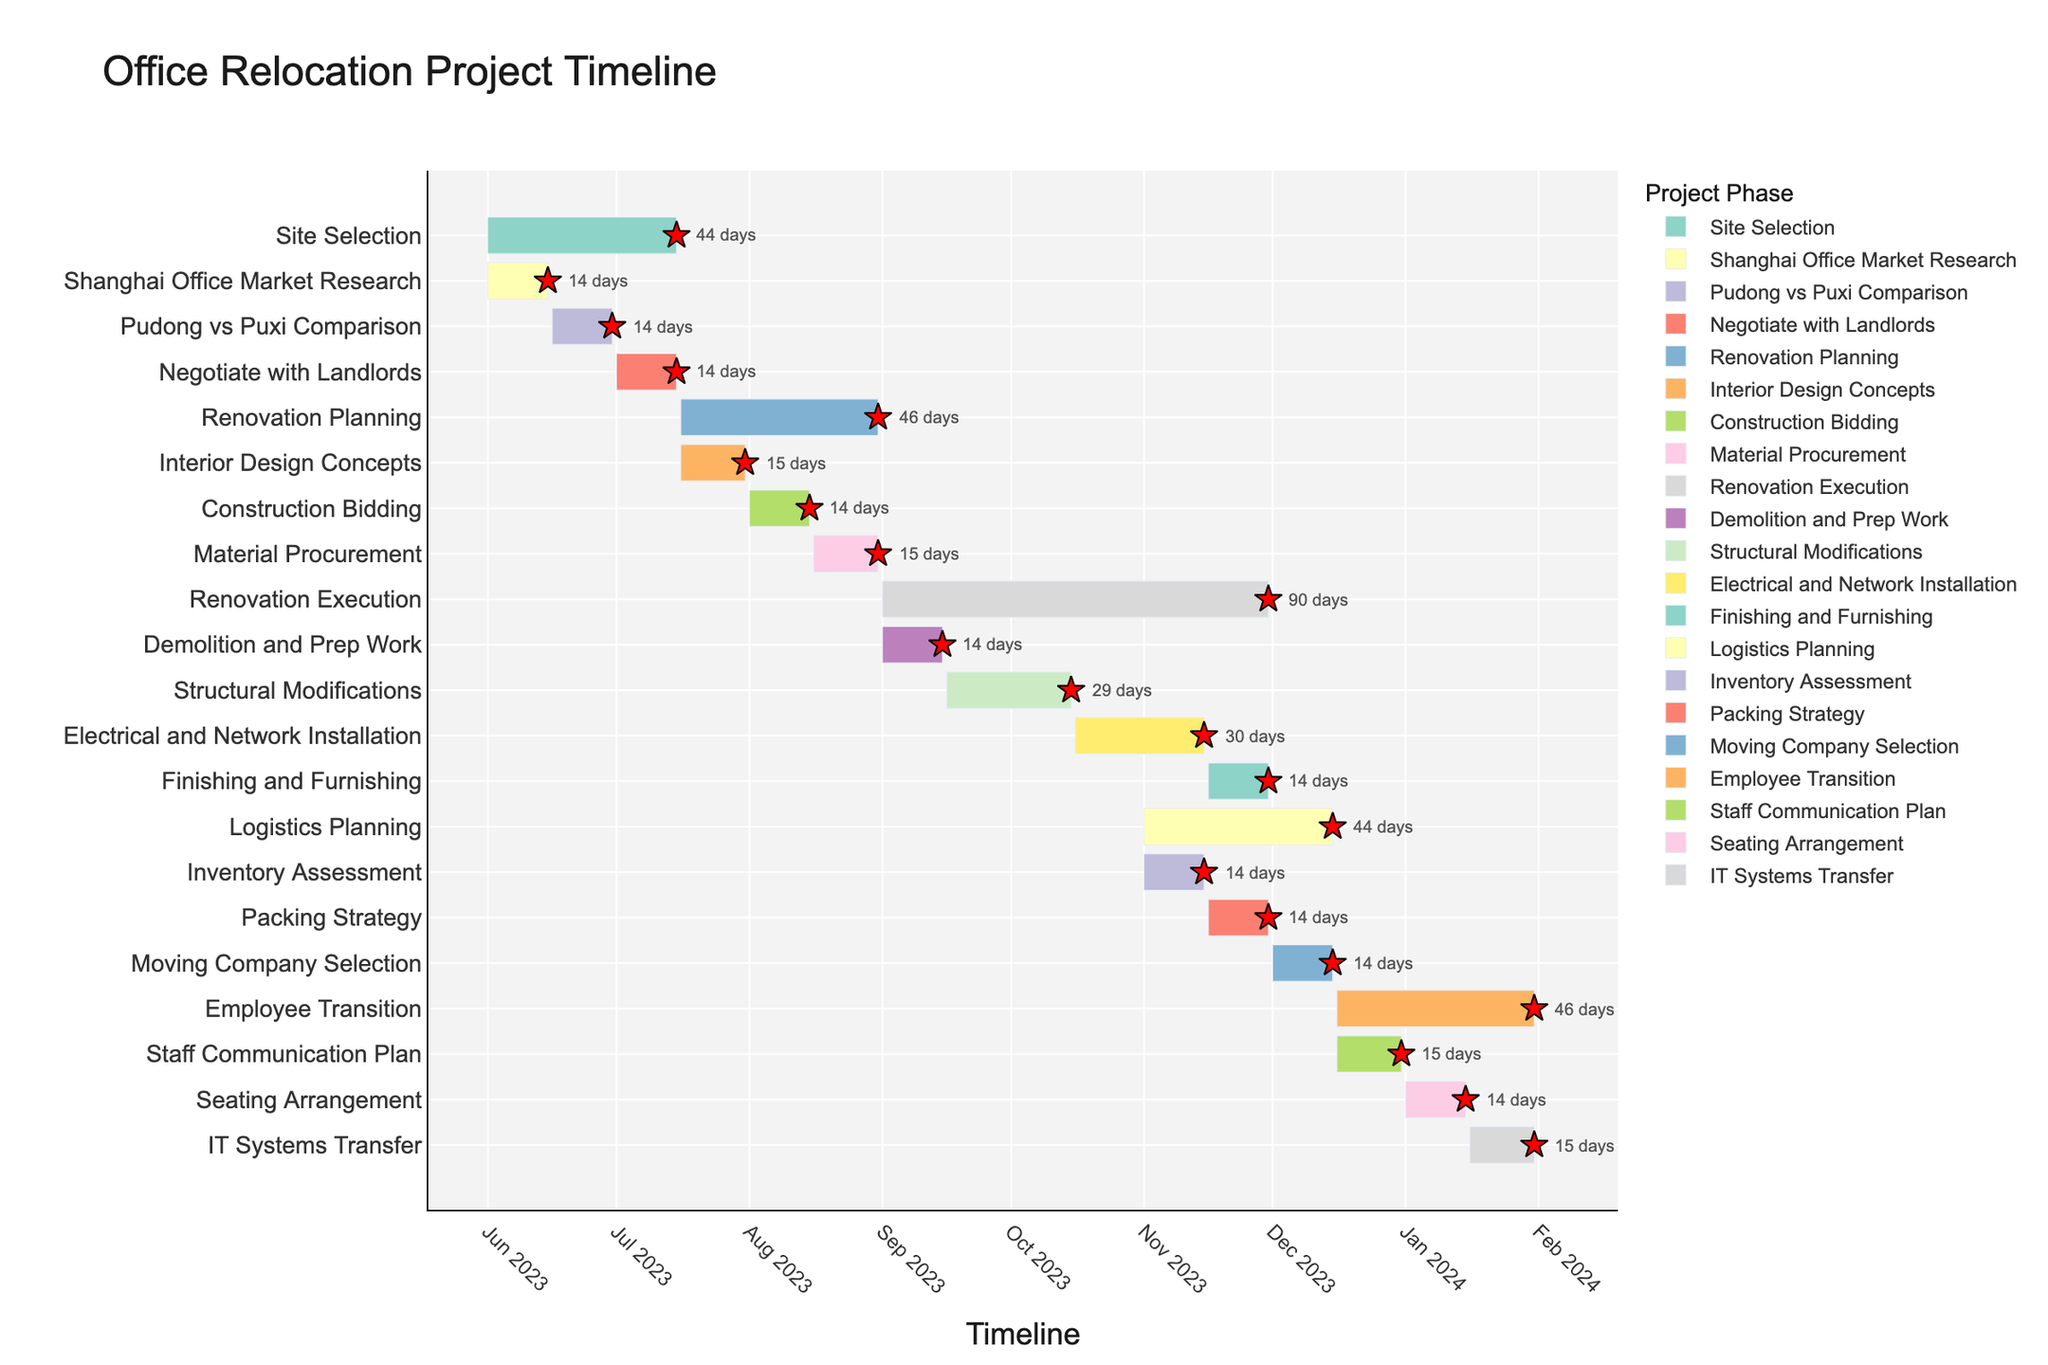What is the title of the Gantt Chart? The title is displayed at the top of the chart, above all the tasks and timelines. It summarizes the content of the chart. The title reads "Office Relocation Project Timeline".
Answer: Office Relocation Project Timeline How many major tasks are listed in the Gantt Chart? The Gantt Chart lists major tasks on the vertical axis. By counting the unique tasks listed on the y-axis, we find the number of major tasks.
Answer: 4 When does the "Renovation Execution" phase start and end? Find the "Renovation Execution" task on the y-axis and then read the start and end dates marked on the x-axis corresponding to that task. The phase starts on 2023-09-01 and ends on 2023-11-30.
Answer: 2023-09-01, 2023-11-30 What is the duration of the "Employee Transition" phase? Locate the "Employee Transition" phase on the y-axis and note the start and end dates. The difference between the end date (2024-01-31) and the start date (2023-12-16) gives the duration, calculated in days. The duration is (2024-01-31) - (2023-12-16) = 46 days
Answer: 46 days Which task has the longest duration, and how long is it? Identify each task along the y-axis and observe the difference between their start and end dates. The task with the greatest difference has the longest duration. "Renovation Execution" starts on 2023-09-01 and ends on 2023-11-30, spanning (2023-11-30) - (2023-09-01) = 90 days.
Answer: Renovation Execution, 90 days Which phase appears directly after the "Site Selection" phase ends? Find the end date of the "Site Selection" phase, which is 2023-07-15, and then see which phase begins immediately after this date. "Renovation Planning" starts on 2023-07-16.
Answer: Renovation Planning How many tasks are ongoing during October 2023? Identify the tasks whose timelines intersect the date range of October 2023. The tasks are overlapping if their start dates are before November and end dates are after September. The tasks are "Renovation Execution", "Structural Modifications", and "Electrical and Network Installation", making a total of three tasks.
Answer: 3 Which two minor tasks in the "Renovation Execution" phase overlap completely in time? Examine the Gantt chart to see the timelines of tasks within the "Renovation Execution" phase. Both "Demolition and Prep Work" (2023-09-01 to 2023-09-15) and "Structural Modifications" (2023-09-16 to 2023-10-15) overlap completely within their specified times. Neither task starts or ends partway through the other's duration.
Answer: Structural Modifications, Electrical and Network Installation What is the relationship between "Packing Strategy" and "Moving Company Selection" in terms of scheduling? On the Gantt chart, find the start and end dates of "Packing Strategy" and "Moving Company Selection". "Packing Strategy" runs from 2023-11-16 to 2023-11-30. "Moving Company Selection" starts on 2023-12-01, right after "Packing Strategy" ends. There is no gap between them.
Answer: "Moving Company Selection" directly follows "Packing Strategy" What are the tasks included in the "Logistics Planning" phase and their individual durations? Look for the clustered tasks under the "Logistics Planning" phase and note their individual start and end dates. Tasks include "Inventory Assessment" (2023-11-01 to 2023-11-15 = 15 days), "Packing Strategy" (2023-11-16 to 2023-11-30 = 15 days), and "Moving Company Selection" (2023-12-01 to 2023-12-15 = 15 days). List their durations.
Answer: Inventory Assessment: 15 days, Packing Strategy: 15 days, Moving Company Selection: 15 days 